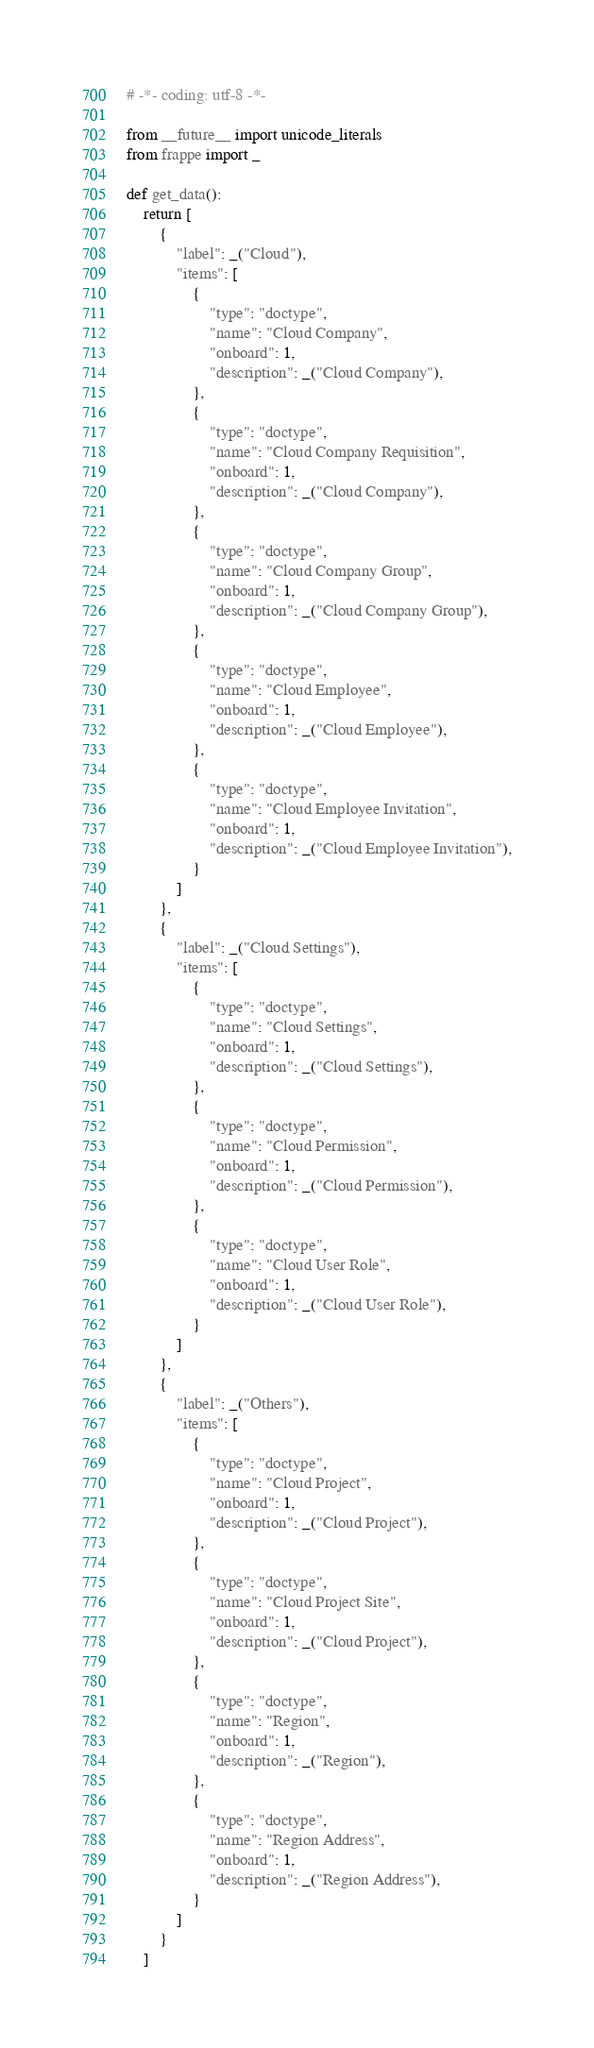<code> <loc_0><loc_0><loc_500><loc_500><_Python_># -*- coding: utf-8 -*-

from __future__ import unicode_literals
from frappe import _

def get_data():
	return [
		{
			"label": _("Cloud"),
			"items": [
				{
					"type": "doctype",
					"name": "Cloud Company",
					"onboard": 1,
					"description": _("Cloud Company"),
				},
				{
					"type": "doctype",
					"name": "Cloud Company Requisition",
					"onboard": 1,
					"description": _("Cloud Company"),
				},
				{
					"type": "doctype",
					"name": "Cloud Company Group",
					"onboard": 1,
					"description": _("Cloud Company Group"),
				},
				{
					"type": "doctype",
					"name": "Cloud Employee",
					"onboard": 1,
					"description": _("Cloud Employee"),
				},
				{
					"type": "doctype",
					"name": "Cloud Employee Invitation",
					"onboard": 1,
					"description": _("Cloud Employee Invitation"),
				}
			]
		},
		{
			"label": _("Cloud Settings"),
			"items": [
				{
					"type": "doctype",
					"name": "Cloud Settings",
					"onboard": 1,
					"description": _("Cloud Settings"),
				},
				{
					"type": "doctype",
					"name": "Cloud Permission",
					"onboard": 1,
					"description": _("Cloud Permission"),
				},
				{
					"type": "doctype",
					"name": "Cloud User Role",
					"onboard": 1,
					"description": _("Cloud User Role"),
				}
			]
		},
		{
			"label": _("Others"),
			"items": [
				{
					"type": "doctype",
					"name": "Cloud Project",
					"onboard": 1,
					"description": _("Cloud Project"),
				},
				{
					"type": "doctype",
					"name": "Cloud Project Site",
					"onboard": 1,
					"description": _("Cloud Project"),
				},
				{
					"type": "doctype",
					"name": "Region",
					"onboard": 1,
					"description": _("Region"),
				},
				{
					"type": "doctype",
					"name": "Region Address",
					"onboard": 1,
					"description": _("Region Address"),
				}
			]
		}
	]
</code> 